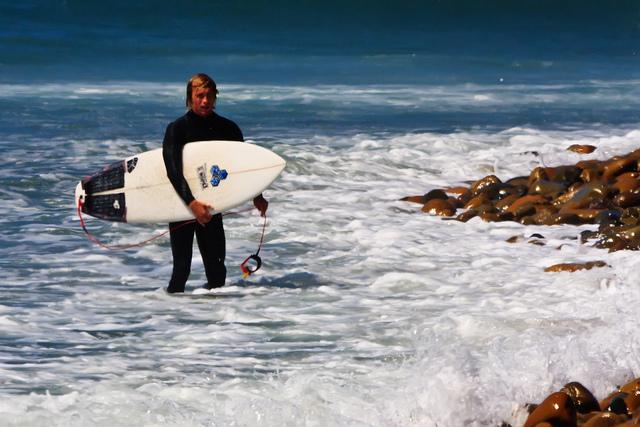Is the man wet?
Short answer required. Yes. What color is the surfboard?
Keep it brief. White. What is the man doing in the water?
Give a very brief answer. Surfing. 